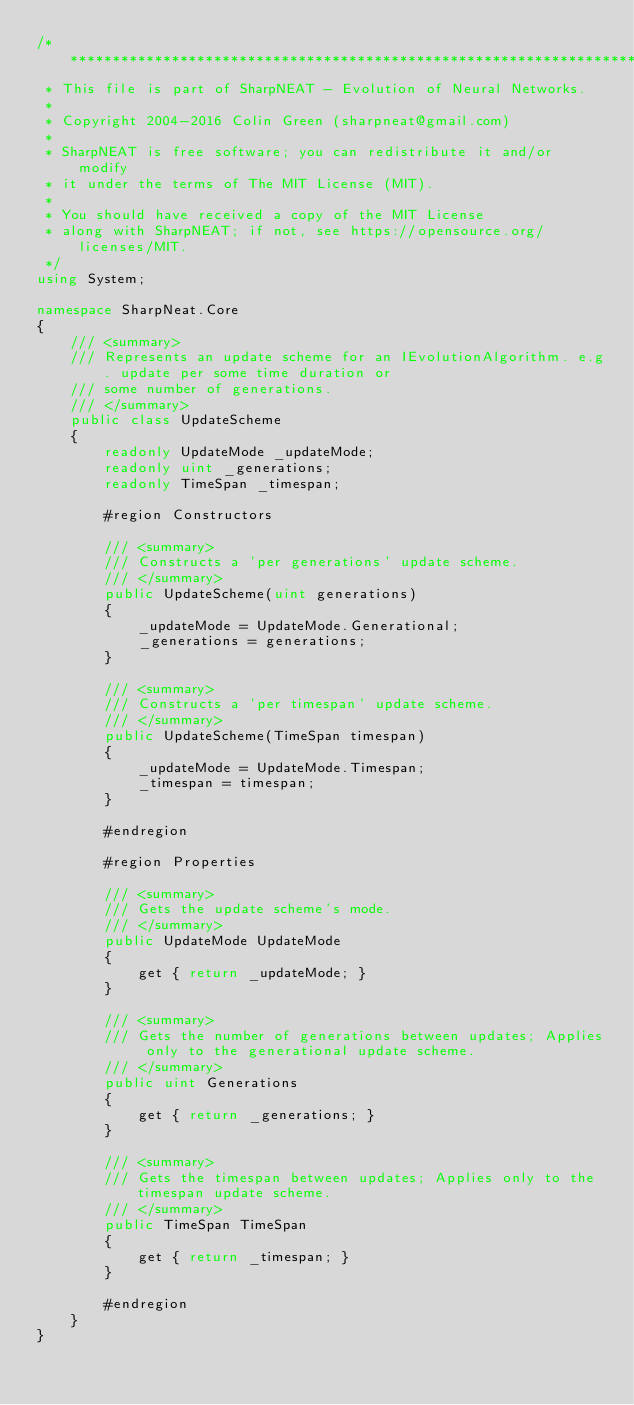Convert code to text. <code><loc_0><loc_0><loc_500><loc_500><_C#_>/* ***************************************************************************
 * This file is part of SharpNEAT - Evolution of Neural Networks.
 * 
 * Copyright 2004-2016 Colin Green (sharpneat@gmail.com)
 *
 * SharpNEAT is free software; you can redistribute it and/or modify
 * it under the terms of The MIT License (MIT).
 *
 * You should have received a copy of the MIT License
 * along with SharpNEAT; if not, see https://opensource.org/licenses/MIT.
 */
using System;

namespace SharpNeat.Core
{
    /// <summary>
    /// Represents an update scheme for an IEvolutionAlgorithm. e.g. update per some time duration or 
    /// some number of generations.
    /// </summary>
    public class UpdateScheme
    {
        readonly UpdateMode _updateMode;
        readonly uint _generations;
        readonly TimeSpan _timespan;

        #region Constructors

        /// <summary>
        /// Constructs a 'per generations' update scheme.
        /// </summary>
        public UpdateScheme(uint generations)
        {
            _updateMode = UpdateMode.Generational;
            _generations = generations;
        }

        /// <summary>
        /// Constructs a 'per timespan' update scheme.
        /// </summary>
        public UpdateScheme(TimeSpan timespan)
        {
            _updateMode = UpdateMode.Timespan;
            _timespan = timespan;
        }

        #endregion

        #region Properties

        /// <summary>
        /// Gets the update scheme's mode.
        /// </summary>
        public UpdateMode UpdateMode
        {
            get { return _updateMode; }
        }

        /// <summary>
        /// Gets the number of generations between updates; Applies only to the generational update scheme.
        /// </summary>
        public uint Generations
        {
            get { return _generations; }
        }

        /// <summary>
        /// Gets the timespan between updates; Applies only to the timespan update scheme.
        /// </summary>
        public TimeSpan TimeSpan
        {
            get { return _timespan; }
        }

        #endregion
    }
}
</code> 